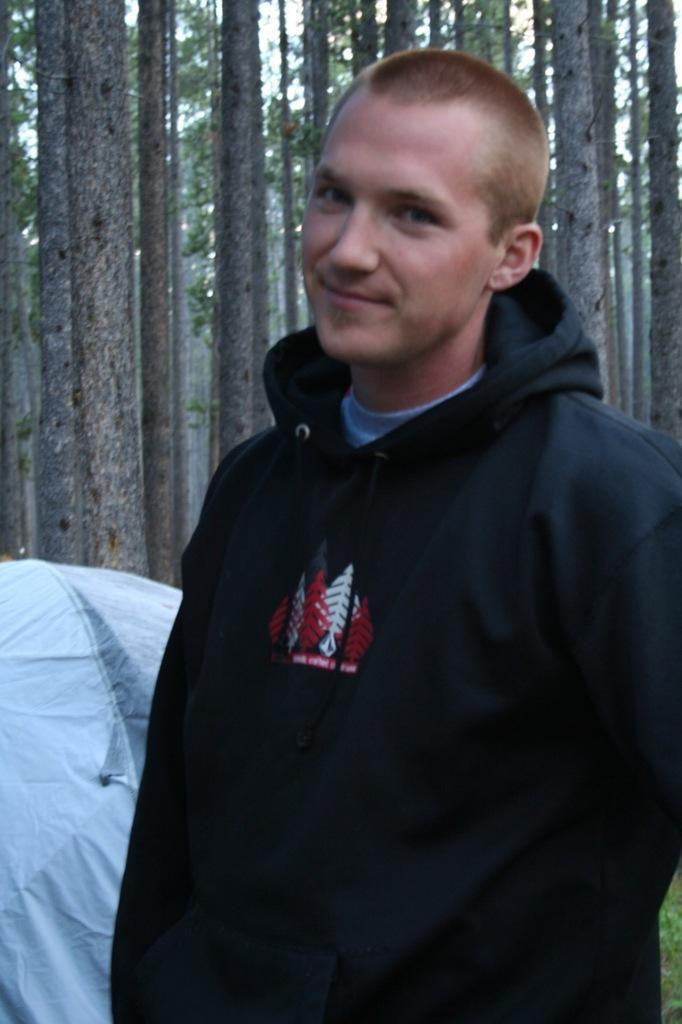Can you describe this image briefly? This image is taken outdoors. In the background there are many trees with leaves and branches. There is a tent. On the right side of the image there is a man and he is standing. 